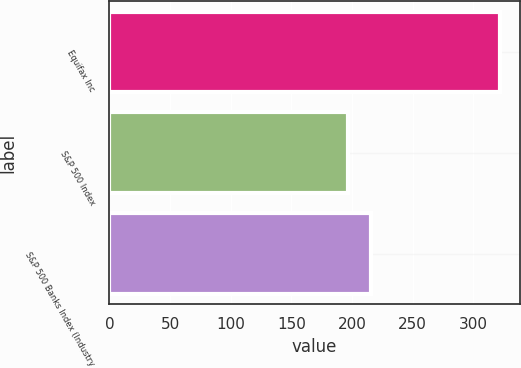Convert chart to OTSL. <chart><loc_0><loc_0><loc_500><loc_500><bar_chart><fcel>Equifax Inc<fcel>S&P 500 Index<fcel>S&P 500 Banks Index (Industry<nl><fcel>321.99<fcel>196.31<fcel>215.65<nl></chart> 